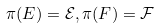<formula> <loc_0><loc_0><loc_500><loc_500>\pi ( E ) = \mathcal { E } , \pi ( F ) = \mathcal { F }</formula> 